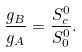<formula> <loc_0><loc_0><loc_500><loc_500>\frac { g _ { B } } { g _ { A } } = \frac { S ^ { 0 } _ { c } } { S ^ { 0 } _ { 0 } } .</formula> 